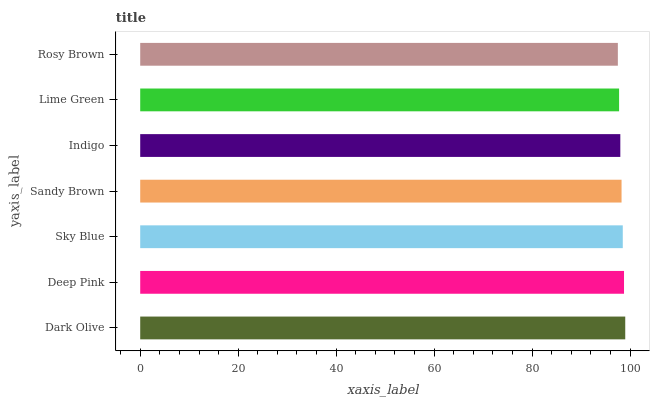Is Rosy Brown the minimum?
Answer yes or no. Yes. Is Dark Olive the maximum?
Answer yes or no. Yes. Is Deep Pink the minimum?
Answer yes or no. No. Is Deep Pink the maximum?
Answer yes or no. No. Is Dark Olive greater than Deep Pink?
Answer yes or no. Yes. Is Deep Pink less than Dark Olive?
Answer yes or no. Yes. Is Deep Pink greater than Dark Olive?
Answer yes or no. No. Is Dark Olive less than Deep Pink?
Answer yes or no. No. Is Sandy Brown the high median?
Answer yes or no. Yes. Is Sandy Brown the low median?
Answer yes or no. Yes. Is Lime Green the high median?
Answer yes or no. No. Is Indigo the low median?
Answer yes or no. No. 